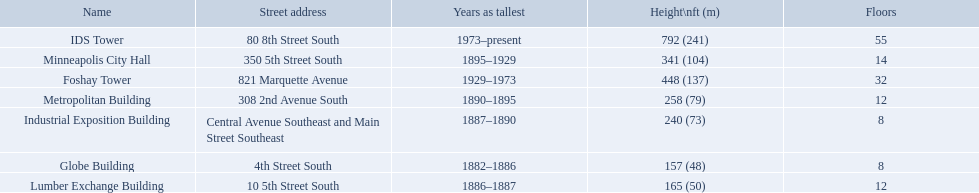What are the tallest buildings in minneapolis? Globe Building, Lumber Exchange Building, Industrial Exposition Building, Metropolitan Building, Minneapolis City Hall, Foshay Tower, IDS Tower. Which of those have 8 floors? Globe Building, Industrial Exposition Building. Of those, which is 240 ft tall? Industrial Exposition Building. Could you help me parse every detail presented in this table? {'header': ['Name', 'Street address', 'Years as tallest', 'Height\\nft (m)', 'Floors'], 'rows': [['IDS Tower', '80 8th Street South', '1973–present', '792 (241)', '55'], ['Minneapolis City Hall', '350 5th Street South', '1895–1929', '341 (104)', '14'], ['Foshay Tower', '821 Marquette Avenue', '1929–1973', '448 (137)', '32'], ['Metropolitan Building', '308 2nd Avenue South', '1890–1895', '258 (79)', '12'], ['Industrial Exposition Building', 'Central Avenue Southeast and Main Street Southeast', '1887–1890', '240 (73)', '8'], ['Globe Building', '4th Street South', '1882–1886', '157 (48)', '8'], ['Lumber Exchange Building', '10 5th Street South', '1886–1887', '165 (50)', '12']]} How tall is the metropolitan building? 258 (79). How tall is the lumber exchange building? 165 (50). Is the metropolitan or lumber exchange building taller? Metropolitan Building. What are all the building names? Globe Building, Lumber Exchange Building, Industrial Exposition Building, Metropolitan Building, Minneapolis City Hall, Foshay Tower, IDS Tower. And their heights? 157 (48), 165 (50), 240 (73), 258 (79), 341 (104), 448 (137), 792 (241). Between metropolitan building and lumber exchange building, which is taller? Metropolitan Building. 